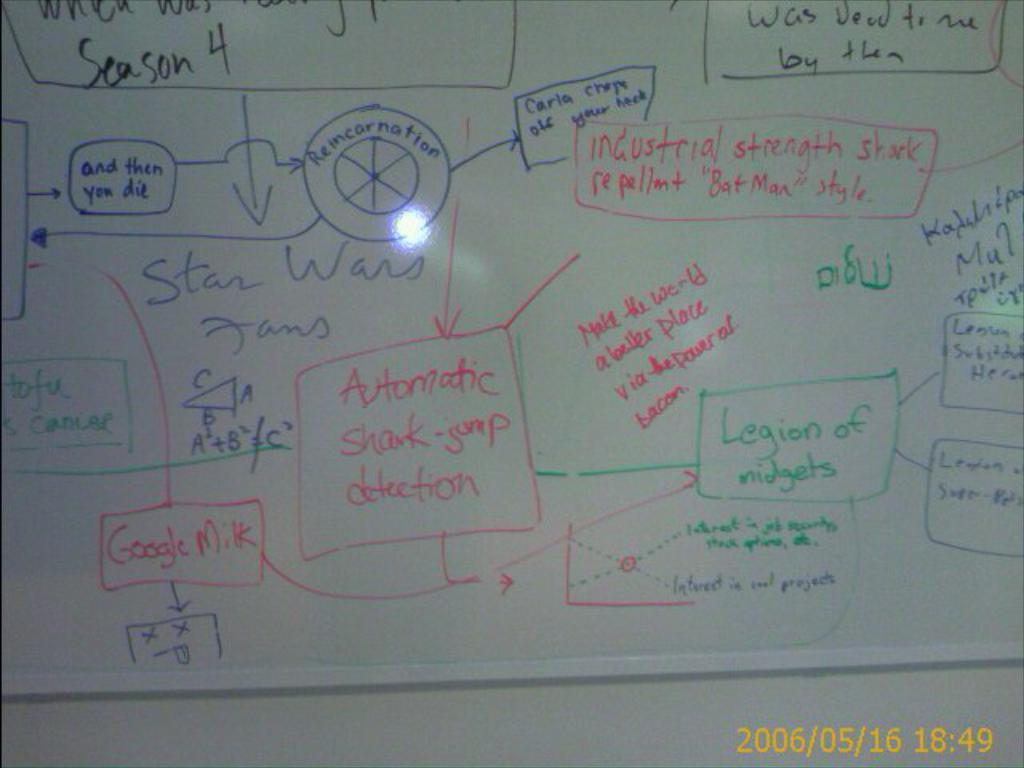<image>
Provide a brief description of the given image. White board with a blue box that says "and then you die" on it. 